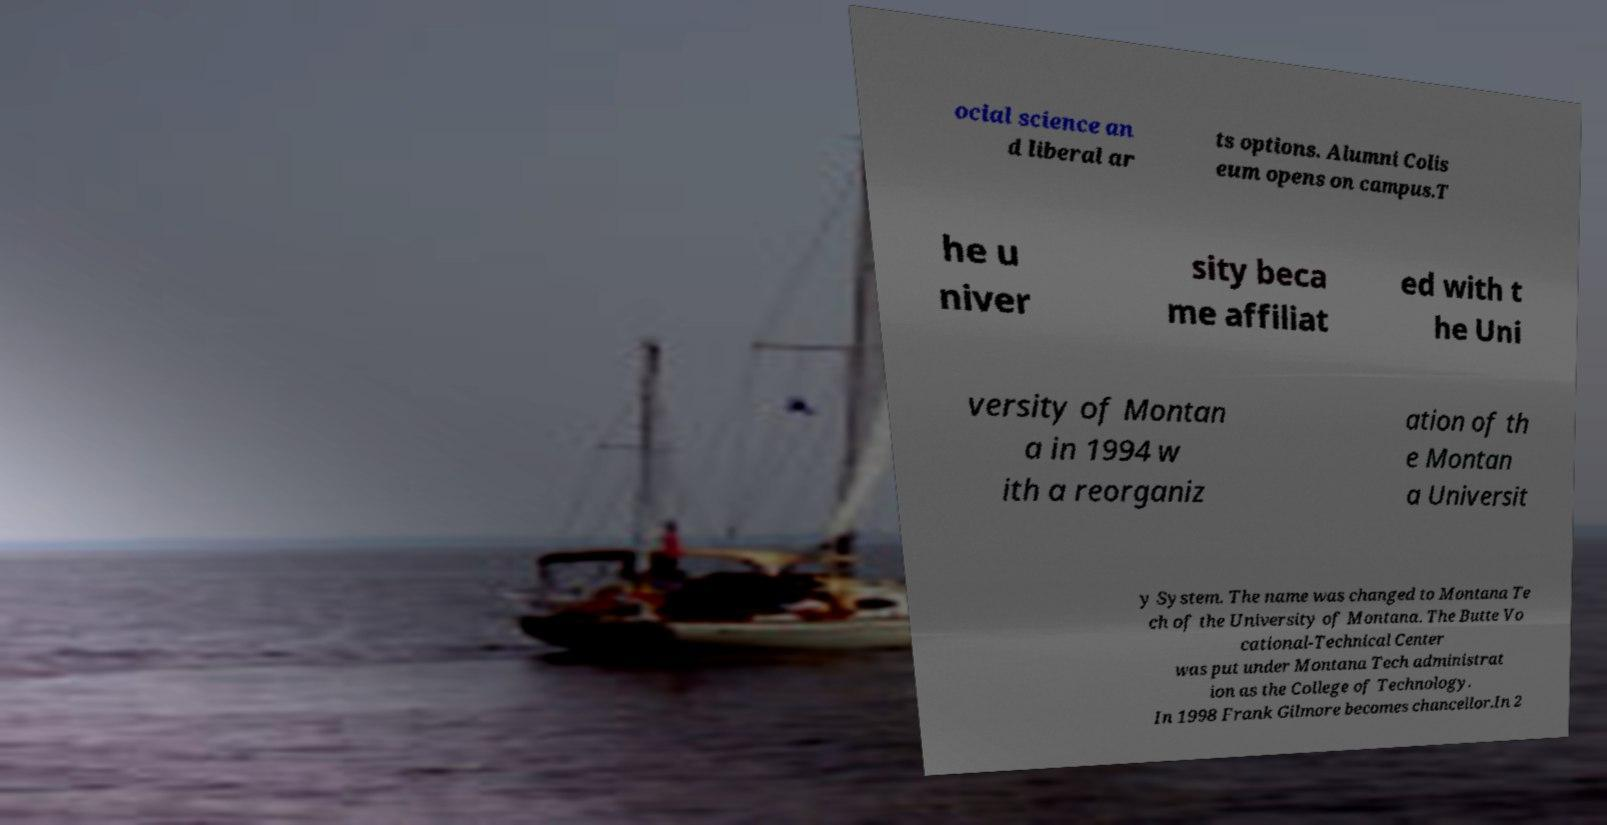For documentation purposes, I need the text within this image transcribed. Could you provide that? ocial science an d liberal ar ts options. Alumni Colis eum opens on campus.T he u niver sity beca me affiliat ed with t he Uni versity of Montan a in 1994 w ith a reorganiz ation of th e Montan a Universit y System. The name was changed to Montana Te ch of the University of Montana. The Butte Vo cational-Technical Center was put under Montana Tech administrat ion as the College of Technology. In 1998 Frank Gilmore becomes chancellor.In 2 